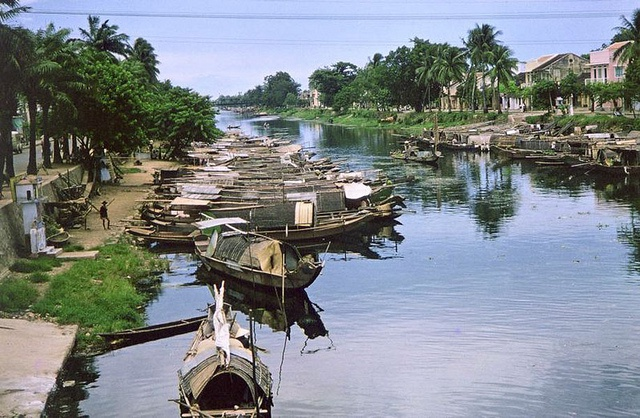Describe the objects in this image and their specific colors. I can see boat in black, lightgray, darkgray, and gray tones, boat in black, gray, darkgreen, and tan tones, boat in black, gray, darkgreen, and lightgray tones, boat in black, gray, lightgray, and darkgray tones, and boat in black, darkgray, gray, and lightgray tones in this image. 